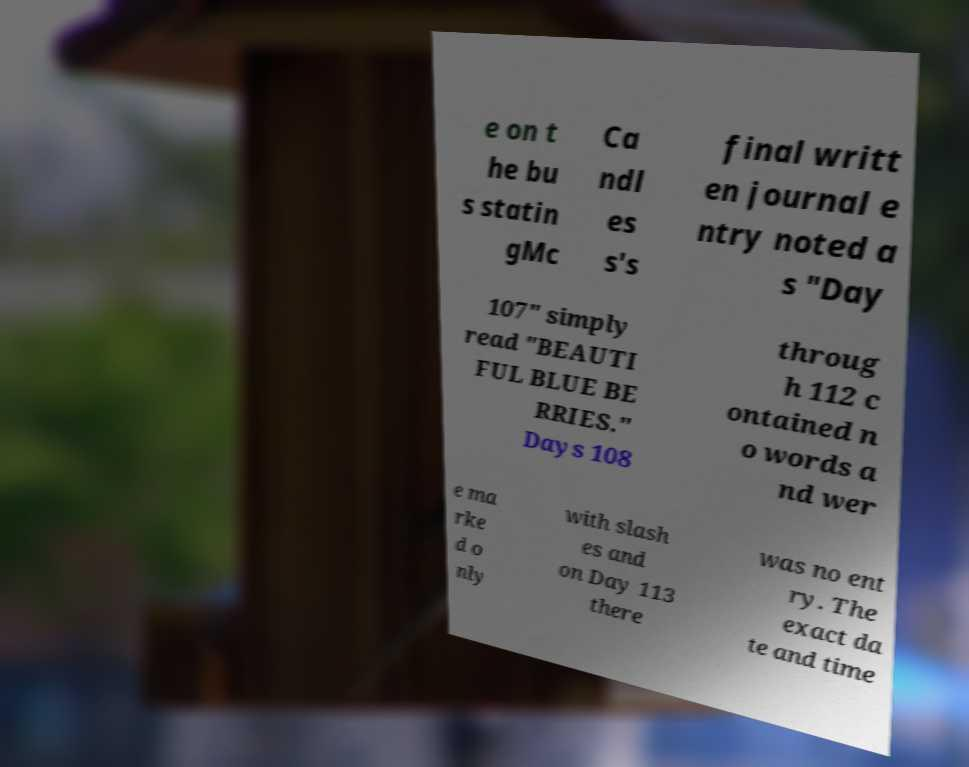Can you read and provide the text displayed in the image?This photo seems to have some interesting text. Can you extract and type it out for me? e on t he bu s statin gMc Ca ndl es s's final writt en journal e ntry noted a s "Day 107" simply read "BEAUTI FUL BLUE BE RRIES." Days 108 throug h 112 c ontained n o words a nd wer e ma rke d o nly with slash es and on Day 113 there was no ent ry. The exact da te and time 